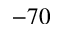Convert formula to latex. <formula><loc_0><loc_0><loc_500><loc_500>- 7 0</formula> 